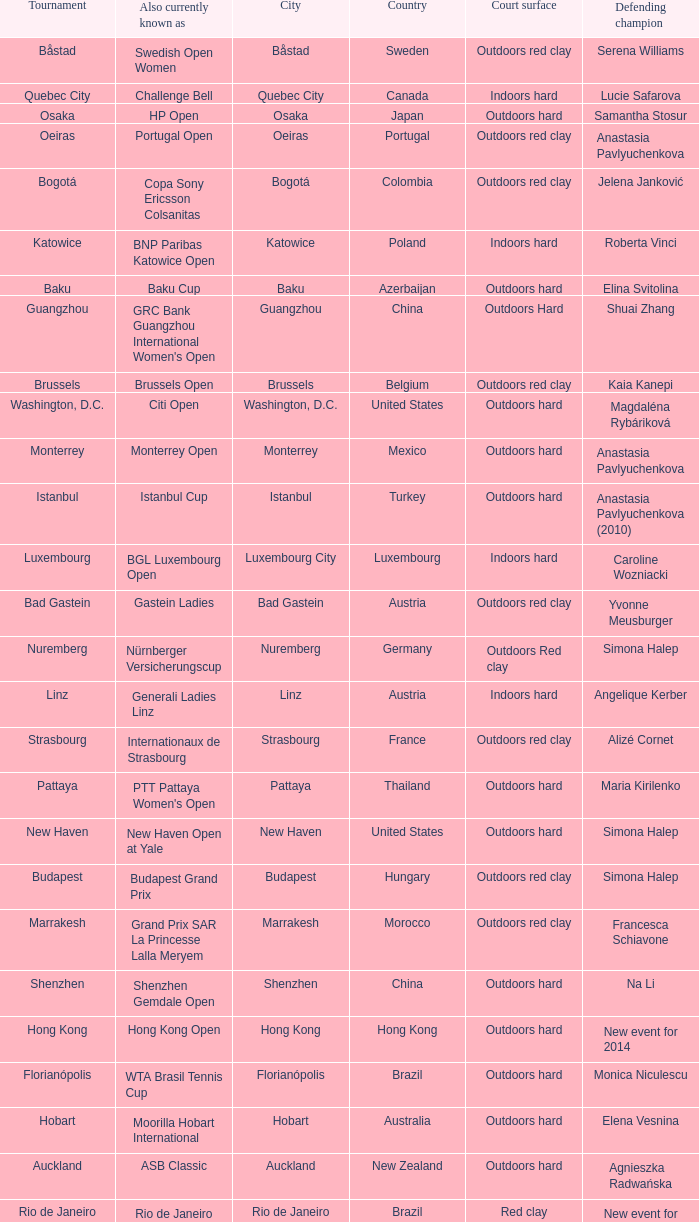How many tournaments are also currently known as the hp open? 1.0. 